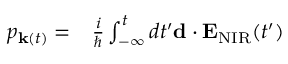Convert formula to latex. <formula><loc_0><loc_0><loc_500><loc_500>\begin{array} { r l } { p _ { { k } ( t ) } = } & \frac { i } { } \int _ { - \infty } ^ { t } d t ^ { \prime } { d } \cdot { E } _ { N I R } ( t ^ { \prime } ) } \end{array}</formula> 